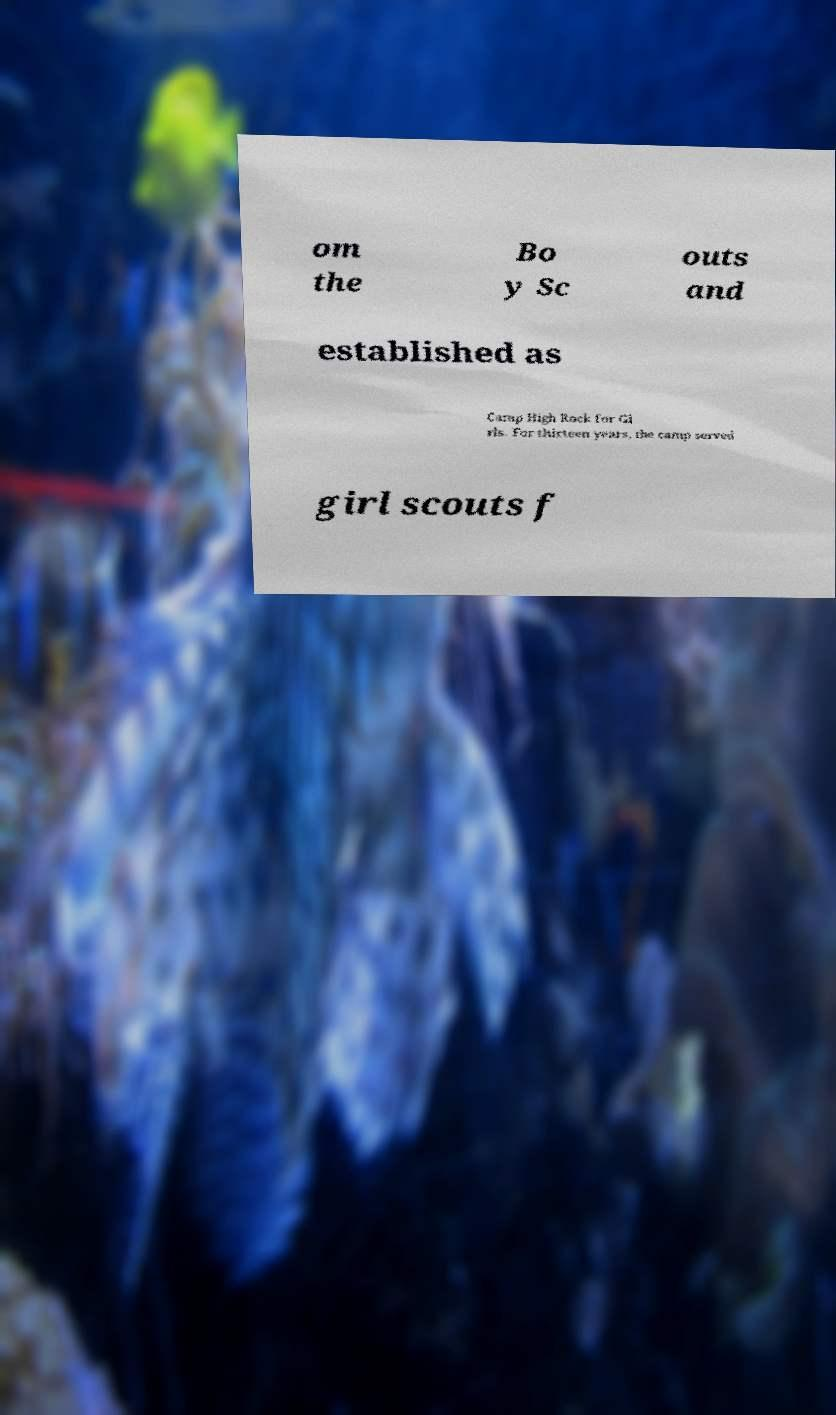There's text embedded in this image that I need extracted. Can you transcribe it verbatim? om the Bo y Sc outs and established as Camp High Rock for Gi rls. For thirteen years, the camp served girl scouts f 